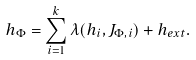<formula> <loc_0><loc_0><loc_500><loc_500>h _ { \Phi } = \sum _ { i = 1 } ^ { k } \lambda ( h _ { i } , J _ { \Phi , i } ) + h _ { e x t } .</formula> 